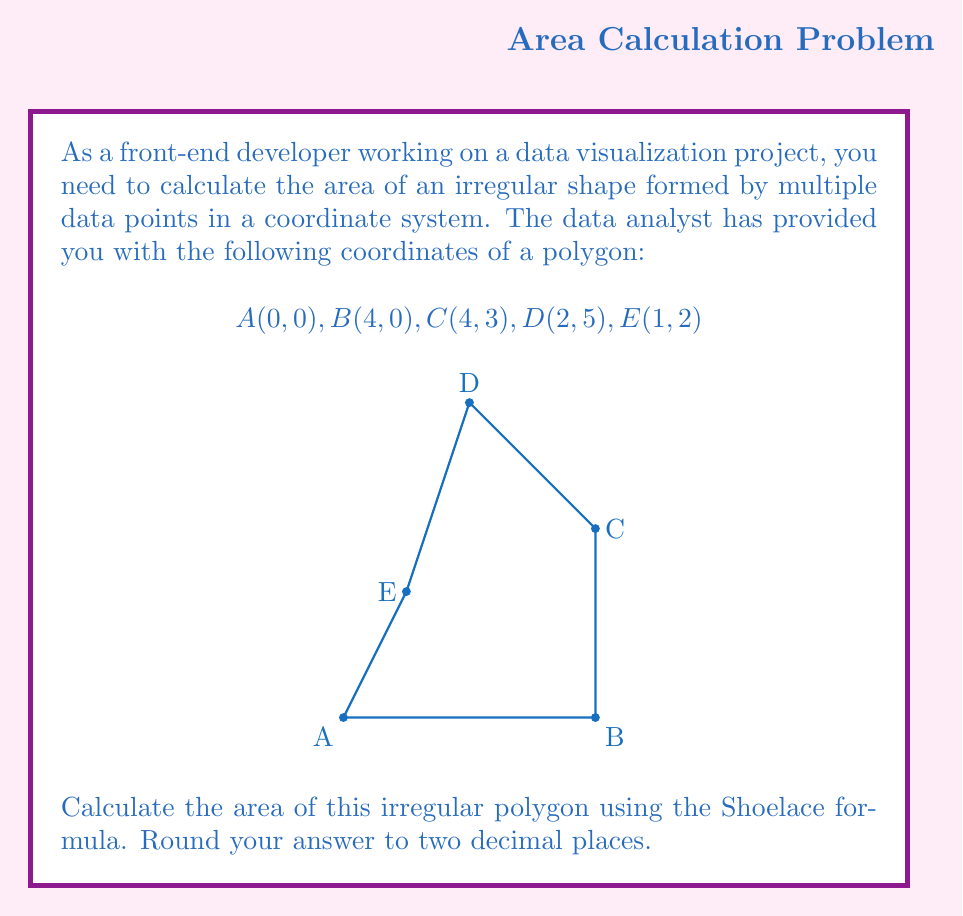Show me your answer to this math problem. To find the area of this irregular polygon, we'll use the Shoelace formula (also known as the surveyor's formula). Here's how to solve it step-by-step:

1) The Shoelace formula for a polygon with vertices $(x_1, y_1), (x_2, y_2), ..., (x_n, y_n)$ is:

   $$Area = \frac{1}{2}|(x_1y_2 + x_2y_3 + ... + x_ny_1) - (y_1x_2 + y_2x_3 + ... + y_nx_1)|$$

2) Let's organize our data:
   $$A(x_1,y_1) = (0,0)$$
   $$B(x_2,y_2) = (4,0)$$
   $$C(x_3,y_3) = (4,3)$$
   $$D(x_4,y_4) = (2,5)$$
   $$E(x_5,y_5) = (1,2)$$

3) Now, let's apply the formula:

   $$Area = \frac{1}{2}|(0 \cdot 0 + 4 \cdot 3 + 4 \cdot 5 + 2 \cdot 2 + 1 \cdot 0) - (0 \cdot 4 + 0 \cdot 4 + 3 \cdot 2 + 5 \cdot 1 + 2 \cdot 0)|$$

4) Simplify:
   $$Area = \frac{1}{2}|(0 + 12 + 20 + 4 + 0) - (0 + 0 + 6 + 5 + 0)|$$
   $$Area = \frac{1}{2}|36 - 11|$$
   $$Area = \frac{1}{2}|25|$$
   $$Area = \frac{25}{2}$$
   $$Area = 12.5$$

5) Rounding to two decimal places:
   $$Area \approx 12.50$$
Answer: 12.50 square units 